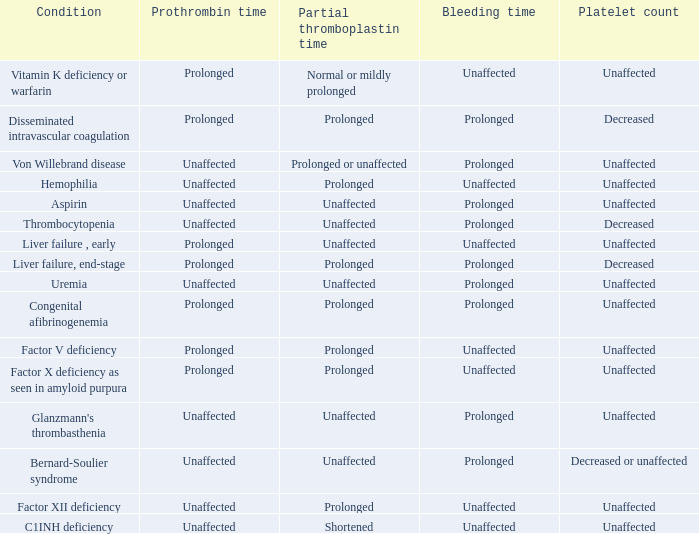Which Condition has a Bleeding time of unaffected, and a Partial thromboplastin time of prolonged, and a Prothrombin time of unaffected? Hemophilia, Factor XII deficiency. 